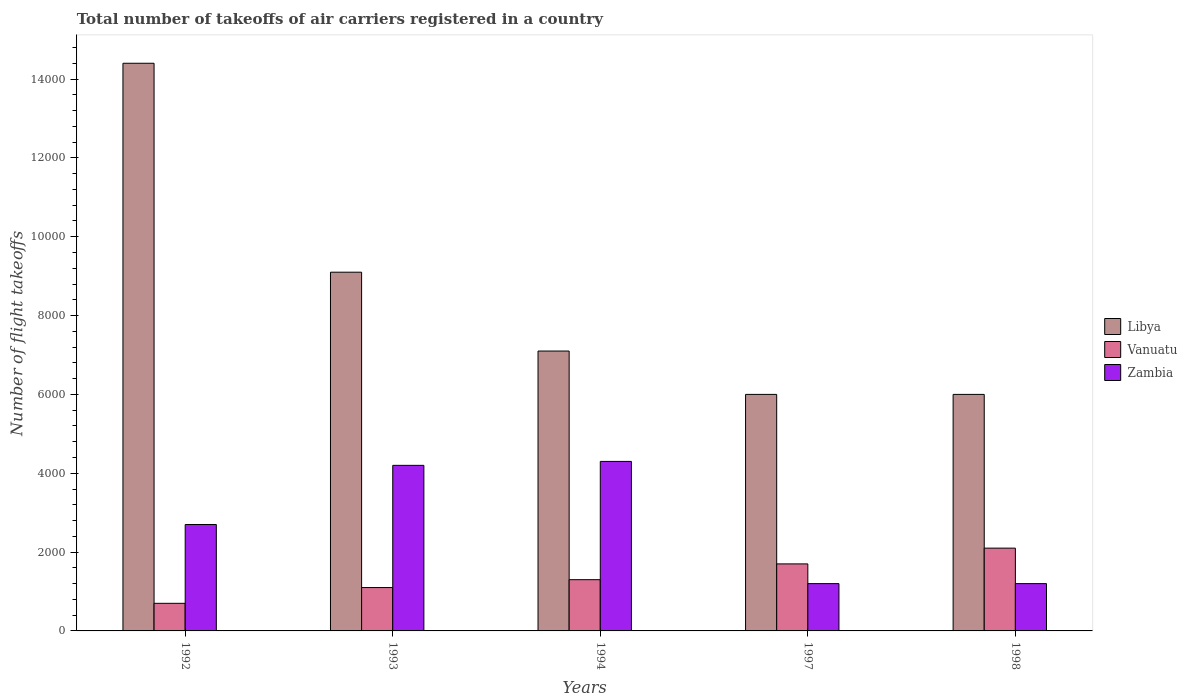How many groups of bars are there?
Your answer should be very brief. 5. Are the number of bars per tick equal to the number of legend labels?
Provide a short and direct response. Yes. Are the number of bars on each tick of the X-axis equal?
Keep it short and to the point. Yes. How many bars are there on the 4th tick from the left?
Your response must be concise. 3. In how many cases, is the number of bars for a given year not equal to the number of legend labels?
Keep it short and to the point. 0. What is the total number of flight takeoffs in Zambia in 1998?
Provide a short and direct response. 1200. Across all years, what is the maximum total number of flight takeoffs in Vanuatu?
Make the answer very short. 2100. Across all years, what is the minimum total number of flight takeoffs in Zambia?
Keep it short and to the point. 1200. In which year was the total number of flight takeoffs in Vanuatu maximum?
Your answer should be very brief. 1998. In which year was the total number of flight takeoffs in Libya minimum?
Your answer should be very brief. 1997. What is the total total number of flight takeoffs in Zambia in the graph?
Make the answer very short. 1.36e+04. What is the difference between the total number of flight takeoffs in Libya in 1992 and that in 1998?
Provide a short and direct response. 8400. What is the difference between the total number of flight takeoffs in Vanuatu in 1997 and the total number of flight takeoffs in Zambia in 1994?
Offer a very short reply. -2600. What is the average total number of flight takeoffs in Libya per year?
Offer a terse response. 8520. In the year 1993, what is the difference between the total number of flight takeoffs in Libya and total number of flight takeoffs in Vanuatu?
Keep it short and to the point. 8000. In how many years, is the total number of flight takeoffs in Zambia greater than 10000?
Offer a very short reply. 0. What is the ratio of the total number of flight takeoffs in Vanuatu in 1992 to that in 1993?
Your response must be concise. 0.64. Is the total number of flight takeoffs in Libya in 1992 less than that in 1993?
Your answer should be compact. No. Is the difference between the total number of flight takeoffs in Libya in 1997 and 1998 greater than the difference between the total number of flight takeoffs in Vanuatu in 1997 and 1998?
Offer a very short reply. Yes. What is the difference between the highest and the second highest total number of flight takeoffs in Libya?
Provide a succinct answer. 5300. What is the difference between the highest and the lowest total number of flight takeoffs in Vanuatu?
Ensure brevity in your answer.  1400. Is the sum of the total number of flight takeoffs in Libya in 1992 and 1998 greater than the maximum total number of flight takeoffs in Zambia across all years?
Your response must be concise. Yes. What does the 3rd bar from the left in 1998 represents?
Your answer should be compact. Zambia. What does the 1st bar from the right in 1998 represents?
Ensure brevity in your answer.  Zambia. Is it the case that in every year, the sum of the total number of flight takeoffs in Vanuatu and total number of flight takeoffs in Libya is greater than the total number of flight takeoffs in Zambia?
Keep it short and to the point. Yes. How many bars are there?
Your response must be concise. 15. Are all the bars in the graph horizontal?
Offer a very short reply. No. Does the graph contain any zero values?
Offer a very short reply. No. Does the graph contain grids?
Your response must be concise. No. How are the legend labels stacked?
Your answer should be very brief. Vertical. What is the title of the graph?
Your answer should be compact. Total number of takeoffs of air carriers registered in a country. What is the label or title of the Y-axis?
Provide a short and direct response. Number of flight takeoffs. What is the Number of flight takeoffs in Libya in 1992?
Ensure brevity in your answer.  1.44e+04. What is the Number of flight takeoffs in Vanuatu in 1992?
Make the answer very short. 700. What is the Number of flight takeoffs of Zambia in 1992?
Make the answer very short. 2700. What is the Number of flight takeoffs of Libya in 1993?
Give a very brief answer. 9100. What is the Number of flight takeoffs in Vanuatu in 1993?
Offer a very short reply. 1100. What is the Number of flight takeoffs in Zambia in 1993?
Make the answer very short. 4200. What is the Number of flight takeoffs of Libya in 1994?
Your answer should be compact. 7100. What is the Number of flight takeoffs in Vanuatu in 1994?
Offer a very short reply. 1300. What is the Number of flight takeoffs of Zambia in 1994?
Ensure brevity in your answer.  4300. What is the Number of flight takeoffs in Libya in 1997?
Give a very brief answer. 6000. What is the Number of flight takeoffs of Vanuatu in 1997?
Offer a terse response. 1700. What is the Number of flight takeoffs in Zambia in 1997?
Make the answer very short. 1200. What is the Number of flight takeoffs in Libya in 1998?
Your answer should be compact. 6000. What is the Number of flight takeoffs in Vanuatu in 1998?
Your answer should be compact. 2100. What is the Number of flight takeoffs of Zambia in 1998?
Provide a short and direct response. 1200. Across all years, what is the maximum Number of flight takeoffs in Libya?
Your answer should be compact. 1.44e+04. Across all years, what is the maximum Number of flight takeoffs of Vanuatu?
Keep it short and to the point. 2100. Across all years, what is the maximum Number of flight takeoffs in Zambia?
Give a very brief answer. 4300. Across all years, what is the minimum Number of flight takeoffs of Libya?
Offer a terse response. 6000. Across all years, what is the minimum Number of flight takeoffs of Vanuatu?
Your answer should be compact. 700. Across all years, what is the minimum Number of flight takeoffs in Zambia?
Ensure brevity in your answer.  1200. What is the total Number of flight takeoffs in Libya in the graph?
Give a very brief answer. 4.26e+04. What is the total Number of flight takeoffs of Vanuatu in the graph?
Your response must be concise. 6900. What is the total Number of flight takeoffs of Zambia in the graph?
Offer a very short reply. 1.36e+04. What is the difference between the Number of flight takeoffs in Libya in 1992 and that in 1993?
Your answer should be very brief. 5300. What is the difference between the Number of flight takeoffs of Vanuatu in 1992 and that in 1993?
Your answer should be compact. -400. What is the difference between the Number of flight takeoffs in Zambia in 1992 and that in 1993?
Make the answer very short. -1500. What is the difference between the Number of flight takeoffs of Libya in 1992 and that in 1994?
Your response must be concise. 7300. What is the difference between the Number of flight takeoffs in Vanuatu in 1992 and that in 1994?
Give a very brief answer. -600. What is the difference between the Number of flight takeoffs of Zambia in 1992 and that in 1994?
Your response must be concise. -1600. What is the difference between the Number of flight takeoffs of Libya in 1992 and that in 1997?
Offer a very short reply. 8400. What is the difference between the Number of flight takeoffs of Vanuatu in 1992 and that in 1997?
Offer a very short reply. -1000. What is the difference between the Number of flight takeoffs in Zambia in 1992 and that in 1997?
Provide a succinct answer. 1500. What is the difference between the Number of flight takeoffs in Libya in 1992 and that in 1998?
Offer a terse response. 8400. What is the difference between the Number of flight takeoffs in Vanuatu in 1992 and that in 1998?
Provide a succinct answer. -1400. What is the difference between the Number of flight takeoffs of Zambia in 1992 and that in 1998?
Ensure brevity in your answer.  1500. What is the difference between the Number of flight takeoffs of Vanuatu in 1993 and that in 1994?
Offer a very short reply. -200. What is the difference between the Number of flight takeoffs of Zambia in 1993 and that in 1994?
Offer a very short reply. -100. What is the difference between the Number of flight takeoffs in Libya in 1993 and that in 1997?
Provide a succinct answer. 3100. What is the difference between the Number of flight takeoffs in Vanuatu in 1993 and that in 1997?
Your answer should be very brief. -600. What is the difference between the Number of flight takeoffs in Zambia in 1993 and that in 1997?
Make the answer very short. 3000. What is the difference between the Number of flight takeoffs in Libya in 1993 and that in 1998?
Provide a short and direct response. 3100. What is the difference between the Number of flight takeoffs of Vanuatu in 1993 and that in 1998?
Your answer should be very brief. -1000. What is the difference between the Number of flight takeoffs of Zambia in 1993 and that in 1998?
Give a very brief answer. 3000. What is the difference between the Number of flight takeoffs in Libya in 1994 and that in 1997?
Provide a succinct answer. 1100. What is the difference between the Number of flight takeoffs in Vanuatu in 1994 and that in 1997?
Offer a terse response. -400. What is the difference between the Number of flight takeoffs in Zambia in 1994 and that in 1997?
Your answer should be very brief. 3100. What is the difference between the Number of flight takeoffs of Libya in 1994 and that in 1998?
Ensure brevity in your answer.  1100. What is the difference between the Number of flight takeoffs of Vanuatu in 1994 and that in 1998?
Your response must be concise. -800. What is the difference between the Number of flight takeoffs in Zambia in 1994 and that in 1998?
Ensure brevity in your answer.  3100. What is the difference between the Number of flight takeoffs in Libya in 1997 and that in 1998?
Give a very brief answer. 0. What is the difference between the Number of flight takeoffs in Vanuatu in 1997 and that in 1998?
Keep it short and to the point. -400. What is the difference between the Number of flight takeoffs in Zambia in 1997 and that in 1998?
Offer a terse response. 0. What is the difference between the Number of flight takeoffs in Libya in 1992 and the Number of flight takeoffs in Vanuatu in 1993?
Your response must be concise. 1.33e+04. What is the difference between the Number of flight takeoffs of Libya in 1992 and the Number of flight takeoffs of Zambia in 1993?
Ensure brevity in your answer.  1.02e+04. What is the difference between the Number of flight takeoffs of Vanuatu in 1992 and the Number of flight takeoffs of Zambia in 1993?
Your answer should be compact. -3500. What is the difference between the Number of flight takeoffs of Libya in 1992 and the Number of flight takeoffs of Vanuatu in 1994?
Ensure brevity in your answer.  1.31e+04. What is the difference between the Number of flight takeoffs in Libya in 1992 and the Number of flight takeoffs in Zambia in 1994?
Provide a succinct answer. 1.01e+04. What is the difference between the Number of flight takeoffs of Vanuatu in 1992 and the Number of flight takeoffs of Zambia in 1994?
Offer a terse response. -3600. What is the difference between the Number of flight takeoffs of Libya in 1992 and the Number of flight takeoffs of Vanuatu in 1997?
Your answer should be compact. 1.27e+04. What is the difference between the Number of flight takeoffs in Libya in 1992 and the Number of flight takeoffs in Zambia in 1997?
Give a very brief answer. 1.32e+04. What is the difference between the Number of flight takeoffs of Vanuatu in 1992 and the Number of flight takeoffs of Zambia in 1997?
Offer a very short reply. -500. What is the difference between the Number of flight takeoffs in Libya in 1992 and the Number of flight takeoffs in Vanuatu in 1998?
Make the answer very short. 1.23e+04. What is the difference between the Number of flight takeoffs of Libya in 1992 and the Number of flight takeoffs of Zambia in 1998?
Offer a terse response. 1.32e+04. What is the difference between the Number of flight takeoffs in Vanuatu in 1992 and the Number of flight takeoffs in Zambia in 1998?
Your answer should be compact. -500. What is the difference between the Number of flight takeoffs of Libya in 1993 and the Number of flight takeoffs of Vanuatu in 1994?
Offer a terse response. 7800. What is the difference between the Number of flight takeoffs in Libya in 1993 and the Number of flight takeoffs in Zambia in 1994?
Give a very brief answer. 4800. What is the difference between the Number of flight takeoffs of Vanuatu in 1993 and the Number of flight takeoffs of Zambia in 1994?
Your answer should be compact. -3200. What is the difference between the Number of flight takeoffs in Libya in 1993 and the Number of flight takeoffs in Vanuatu in 1997?
Your response must be concise. 7400. What is the difference between the Number of flight takeoffs of Libya in 1993 and the Number of flight takeoffs of Zambia in 1997?
Your response must be concise. 7900. What is the difference between the Number of flight takeoffs of Vanuatu in 1993 and the Number of flight takeoffs of Zambia in 1997?
Your answer should be very brief. -100. What is the difference between the Number of flight takeoffs of Libya in 1993 and the Number of flight takeoffs of Vanuatu in 1998?
Provide a succinct answer. 7000. What is the difference between the Number of flight takeoffs of Libya in 1993 and the Number of flight takeoffs of Zambia in 1998?
Provide a short and direct response. 7900. What is the difference between the Number of flight takeoffs of Vanuatu in 1993 and the Number of flight takeoffs of Zambia in 1998?
Offer a very short reply. -100. What is the difference between the Number of flight takeoffs of Libya in 1994 and the Number of flight takeoffs of Vanuatu in 1997?
Your answer should be very brief. 5400. What is the difference between the Number of flight takeoffs in Libya in 1994 and the Number of flight takeoffs in Zambia in 1997?
Provide a succinct answer. 5900. What is the difference between the Number of flight takeoffs in Vanuatu in 1994 and the Number of flight takeoffs in Zambia in 1997?
Provide a succinct answer. 100. What is the difference between the Number of flight takeoffs in Libya in 1994 and the Number of flight takeoffs in Zambia in 1998?
Provide a short and direct response. 5900. What is the difference between the Number of flight takeoffs in Libya in 1997 and the Number of flight takeoffs in Vanuatu in 1998?
Provide a short and direct response. 3900. What is the difference between the Number of flight takeoffs of Libya in 1997 and the Number of flight takeoffs of Zambia in 1998?
Provide a short and direct response. 4800. What is the difference between the Number of flight takeoffs of Vanuatu in 1997 and the Number of flight takeoffs of Zambia in 1998?
Keep it short and to the point. 500. What is the average Number of flight takeoffs in Libya per year?
Your response must be concise. 8520. What is the average Number of flight takeoffs in Vanuatu per year?
Offer a terse response. 1380. What is the average Number of flight takeoffs in Zambia per year?
Give a very brief answer. 2720. In the year 1992, what is the difference between the Number of flight takeoffs in Libya and Number of flight takeoffs in Vanuatu?
Give a very brief answer. 1.37e+04. In the year 1992, what is the difference between the Number of flight takeoffs in Libya and Number of flight takeoffs in Zambia?
Your answer should be compact. 1.17e+04. In the year 1992, what is the difference between the Number of flight takeoffs of Vanuatu and Number of flight takeoffs of Zambia?
Your answer should be compact. -2000. In the year 1993, what is the difference between the Number of flight takeoffs of Libya and Number of flight takeoffs of Vanuatu?
Provide a succinct answer. 8000. In the year 1993, what is the difference between the Number of flight takeoffs in Libya and Number of flight takeoffs in Zambia?
Give a very brief answer. 4900. In the year 1993, what is the difference between the Number of flight takeoffs of Vanuatu and Number of flight takeoffs of Zambia?
Your response must be concise. -3100. In the year 1994, what is the difference between the Number of flight takeoffs in Libya and Number of flight takeoffs in Vanuatu?
Give a very brief answer. 5800. In the year 1994, what is the difference between the Number of flight takeoffs of Libya and Number of flight takeoffs of Zambia?
Your answer should be very brief. 2800. In the year 1994, what is the difference between the Number of flight takeoffs in Vanuatu and Number of flight takeoffs in Zambia?
Ensure brevity in your answer.  -3000. In the year 1997, what is the difference between the Number of flight takeoffs of Libya and Number of flight takeoffs of Vanuatu?
Provide a succinct answer. 4300. In the year 1997, what is the difference between the Number of flight takeoffs in Libya and Number of flight takeoffs in Zambia?
Keep it short and to the point. 4800. In the year 1997, what is the difference between the Number of flight takeoffs in Vanuatu and Number of flight takeoffs in Zambia?
Offer a terse response. 500. In the year 1998, what is the difference between the Number of flight takeoffs of Libya and Number of flight takeoffs of Vanuatu?
Your response must be concise. 3900. In the year 1998, what is the difference between the Number of flight takeoffs of Libya and Number of flight takeoffs of Zambia?
Make the answer very short. 4800. In the year 1998, what is the difference between the Number of flight takeoffs in Vanuatu and Number of flight takeoffs in Zambia?
Keep it short and to the point. 900. What is the ratio of the Number of flight takeoffs in Libya in 1992 to that in 1993?
Make the answer very short. 1.58. What is the ratio of the Number of flight takeoffs of Vanuatu in 1992 to that in 1993?
Your response must be concise. 0.64. What is the ratio of the Number of flight takeoffs in Zambia in 1992 to that in 1993?
Provide a succinct answer. 0.64. What is the ratio of the Number of flight takeoffs of Libya in 1992 to that in 1994?
Offer a terse response. 2.03. What is the ratio of the Number of flight takeoffs of Vanuatu in 1992 to that in 1994?
Make the answer very short. 0.54. What is the ratio of the Number of flight takeoffs of Zambia in 1992 to that in 1994?
Ensure brevity in your answer.  0.63. What is the ratio of the Number of flight takeoffs in Libya in 1992 to that in 1997?
Your answer should be very brief. 2.4. What is the ratio of the Number of flight takeoffs in Vanuatu in 1992 to that in 1997?
Offer a terse response. 0.41. What is the ratio of the Number of flight takeoffs of Zambia in 1992 to that in 1997?
Offer a very short reply. 2.25. What is the ratio of the Number of flight takeoffs in Libya in 1992 to that in 1998?
Give a very brief answer. 2.4. What is the ratio of the Number of flight takeoffs in Zambia in 1992 to that in 1998?
Provide a succinct answer. 2.25. What is the ratio of the Number of flight takeoffs in Libya in 1993 to that in 1994?
Make the answer very short. 1.28. What is the ratio of the Number of flight takeoffs in Vanuatu in 1993 to that in 1994?
Your answer should be very brief. 0.85. What is the ratio of the Number of flight takeoffs in Zambia in 1993 to that in 1994?
Your answer should be very brief. 0.98. What is the ratio of the Number of flight takeoffs in Libya in 1993 to that in 1997?
Provide a short and direct response. 1.52. What is the ratio of the Number of flight takeoffs of Vanuatu in 1993 to that in 1997?
Provide a short and direct response. 0.65. What is the ratio of the Number of flight takeoffs of Zambia in 1993 to that in 1997?
Ensure brevity in your answer.  3.5. What is the ratio of the Number of flight takeoffs of Libya in 1993 to that in 1998?
Provide a short and direct response. 1.52. What is the ratio of the Number of flight takeoffs of Vanuatu in 1993 to that in 1998?
Offer a terse response. 0.52. What is the ratio of the Number of flight takeoffs in Zambia in 1993 to that in 1998?
Offer a terse response. 3.5. What is the ratio of the Number of flight takeoffs in Libya in 1994 to that in 1997?
Ensure brevity in your answer.  1.18. What is the ratio of the Number of flight takeoffs in Vanuatu in 1994 to that in 1997?
Offer a very short reply. 0.76. What is the ratio of the Number of flight takeoffs in Zambia in 1994 to that in 1997?
Keep it short and to the point. 3.58. What is the ratio of the Number of flight takeoffs in Libya in 1994 to that in 1998?
Keep it short and to the point. 1.18. What is the ratio of the Number of flight takeoffs of Vanuatu in 1994 to that in 1998?
Provide a succinct answer. 0.62. What is the ratio of the Number of flight takeoffs in Zambia in 1994 to that in 1998?
Your answer should be very brief. 3.58. What is the ratio of the Number of flight takeoffs in Vanuatu in 1997 to that in 1998?
Your response must be concise. 0.81. What is the difference between the highest and the second highest Number of flight takeoffs of Libya?
Give a very brief answer. 5300. What is the difference between the highest and the second highest Number of flight takeoffs of Vanuatu?
Provide a short and direct response. 400. What is the difference between the highest and the second highest Number of flight takeoffs of Zambia?
Provide a succinct answer. 100. What is the difference between the highest and the lowest Number of flight takeoffs of Libya?
Make the answer very short. 8400. What is the difference between the highest and the lowest Number of flight takeoffs in Vanuatu?
Your answer should be very brief. 1400. What is the difference between the highest and the lowest Number of flight takeoffs in Zambia?
Offer a terse response. 3100. 